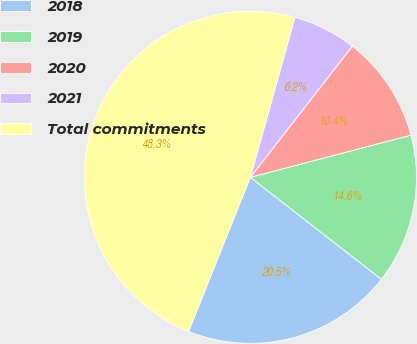Convert chart to OTSL. <chart><loc_0><loc_0><loc_500><loc_500><pie_chart><fcel>2018<fcel>2019<fcel>2020<fcel>2021<fcel>Total commitments<nl><fcel>20.54%<fcel>14.61%<fcel>10.4%<fcel>6.19%<fcel>48.26%<nl></chart> 